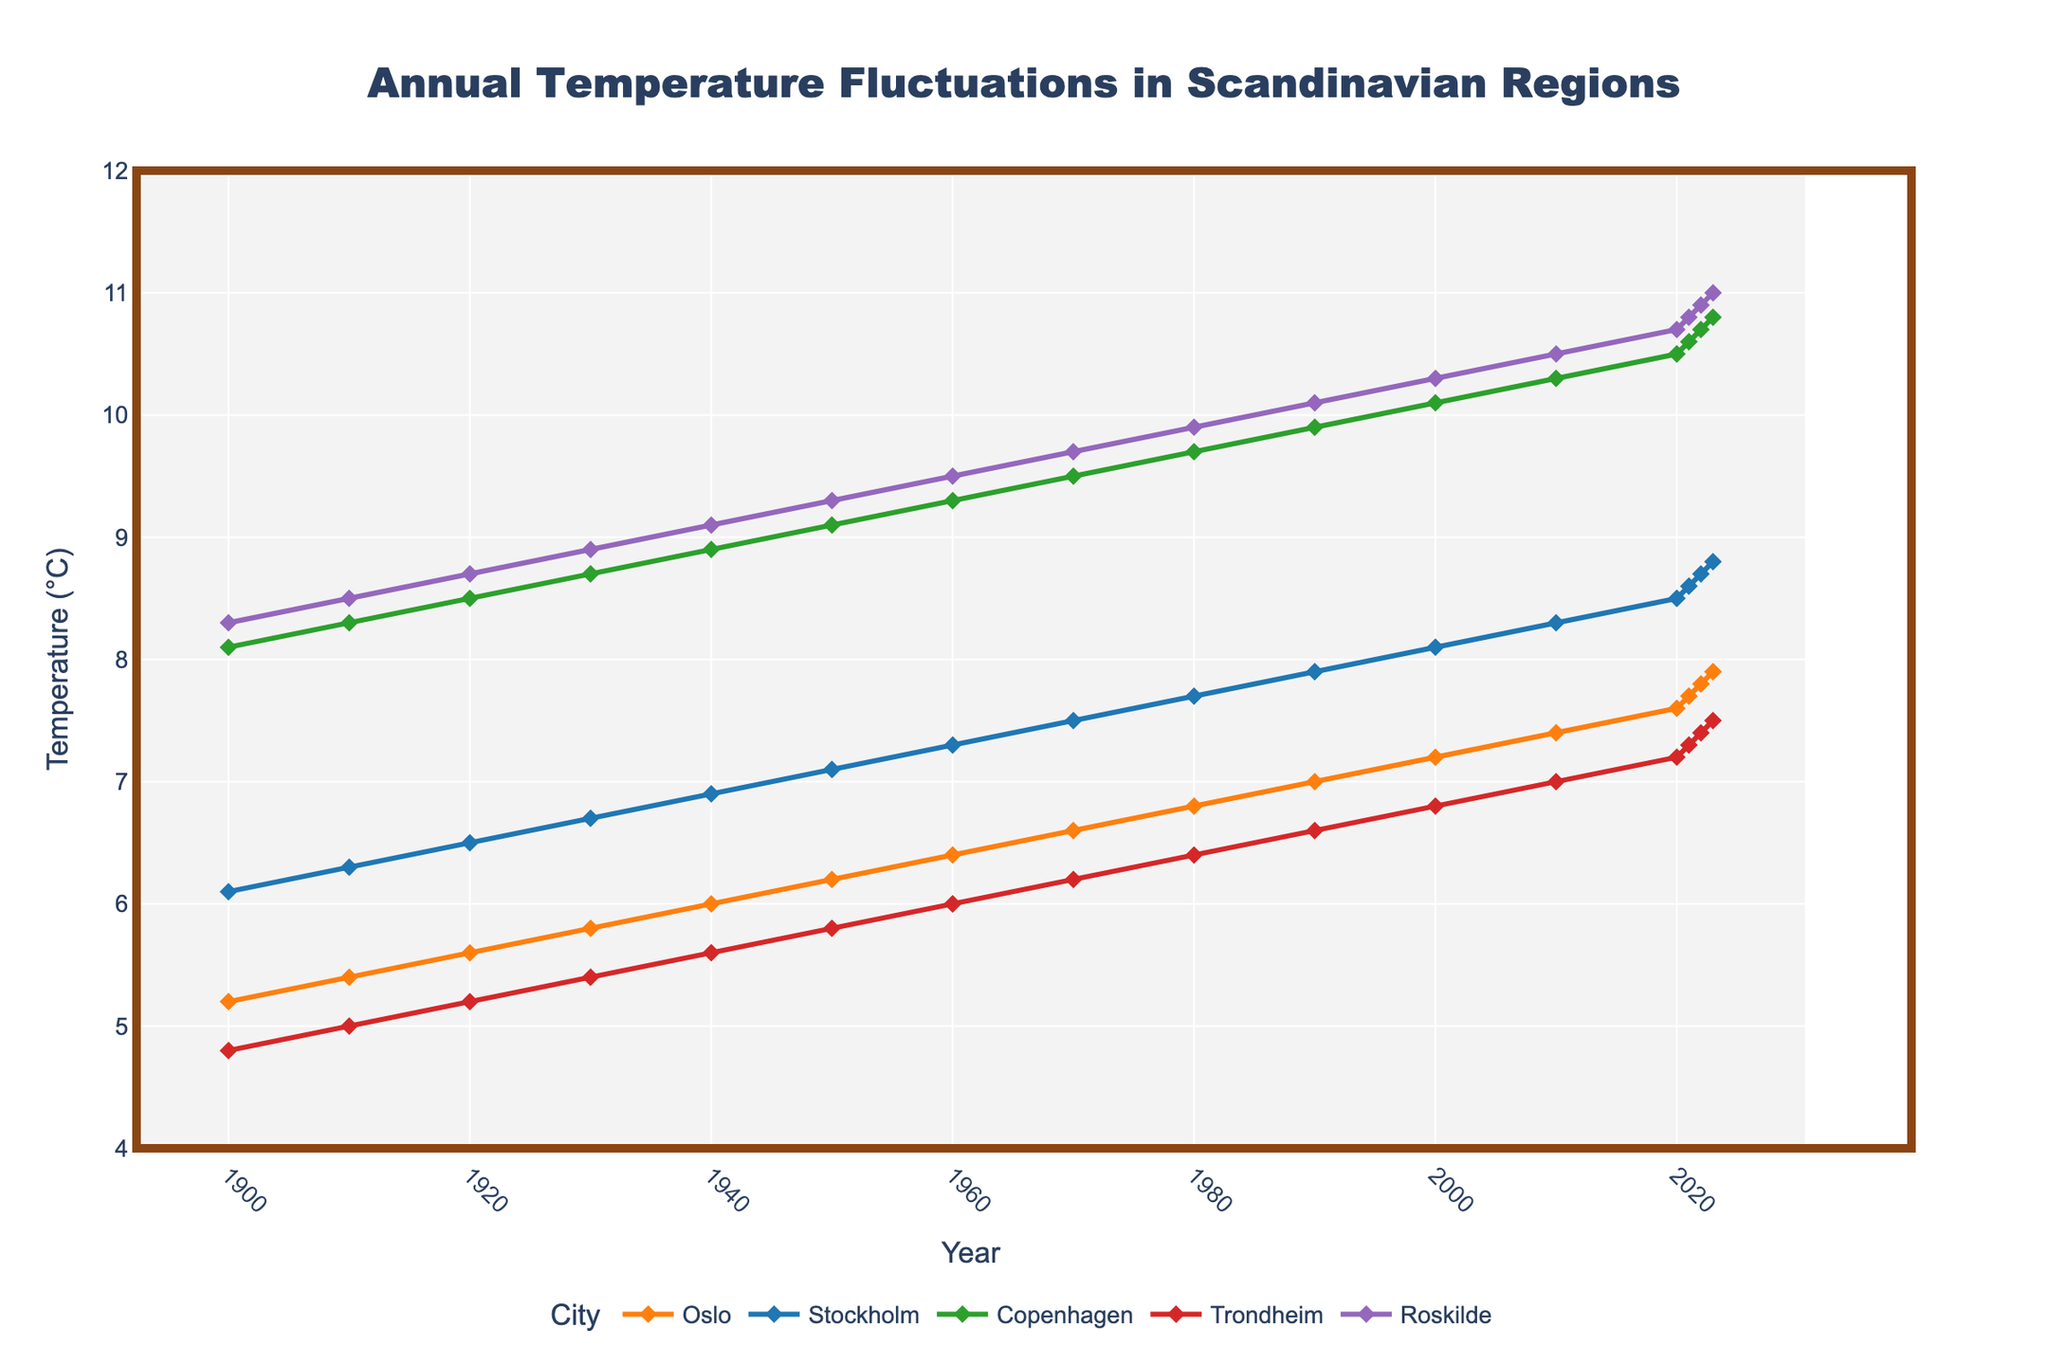Which city had the highest temperature in 2023? In 2023, the temperature for each city is shown on the chart. Roskilde has the highest temperature at 11.0°C.
Answer: Roskilde How much did the annual temperature in Oslo increase from 1900 to 2023? The temperature in Oslo was 5.2°C in 1900 and increased to 7.9°C in 2023. The increase is calculated as 7.9 - 5.2 = 2.7°C.
Answer: 2.7°C Which city experienced the most significant temperature increase from 1900 to 2023? By observing the initial and final data points for each city, the biggest difference is seen in Copenhagen, increasing from 8.1°C in 1900 to 10.8°C in 2023. So, the change is 10.8 - 8.1 = 2.7°C.
Answer: Copenhagen What is the average temperature of Stockholm over the entire period? Summing all the temperatures of Stockholm from 1900 to 2023 and dividing by the total number of years, (6.1 + 6.3 + 6.5 + 6.7 + 6.9 + 7.1 + 7.3 + 7.5 + 7.7 + 7.9 + 8.1 + 8.3 + 8.5 + 8.6 + 8.7 + 8.8) / 16 yields approximately 7.475°C.
Answer: 7.475°C Which city consistently had higher temperatures, Copenhagen or Stockholm? Checking the data for each year, Copenhagen's annual temperature is consistently higher than Stockholm's.
Answer: Copenhagen How much did the temperature in Trondheim change from 2000 to 2023? The temperature in Trondheim in 2000 was 6.8°C and in 2023 was 7.5°C. The change is 7.5 - 6.8 = 0.7°C.
Answer: 0.7°C What is the trend in annual temperatures in Oslo from 1950 to 2023? Observing the line for Oslo from 1950 (6.2°C) to 2023 (7.9°C), there is a clear upward trend with temperatures rising.
Answer: Upward By how much did the temperature increase in Roskilde from 1990 to 2023? Roskilde's temperature in 1990 was 10.1°C and increased to 11.0°C in 2023. The increase is 11.0 - 10.1 = 0.9°C.
Answer: 0.9°C Between Oslo and Trondheim, which city had a steeper increase in temperature from 1900 to 2023? Calculating the rise for Oslo (7.9 - 5.2 = 2.7°C) and Trondheim (7.5 - 4.8 = 2.7°C), both cities experienced the same increase of 2.7°C.
Answer: Equal What was Stockholm's temperature around the year 2000, and how does it compare to its temperature in 2023? Stockholm's temperature in 2000 was 8.1°C and in 2023 was 8.8°C. The increase is 8.8 - 8.1 = 0.7°C.
Answer: 0.7°C 